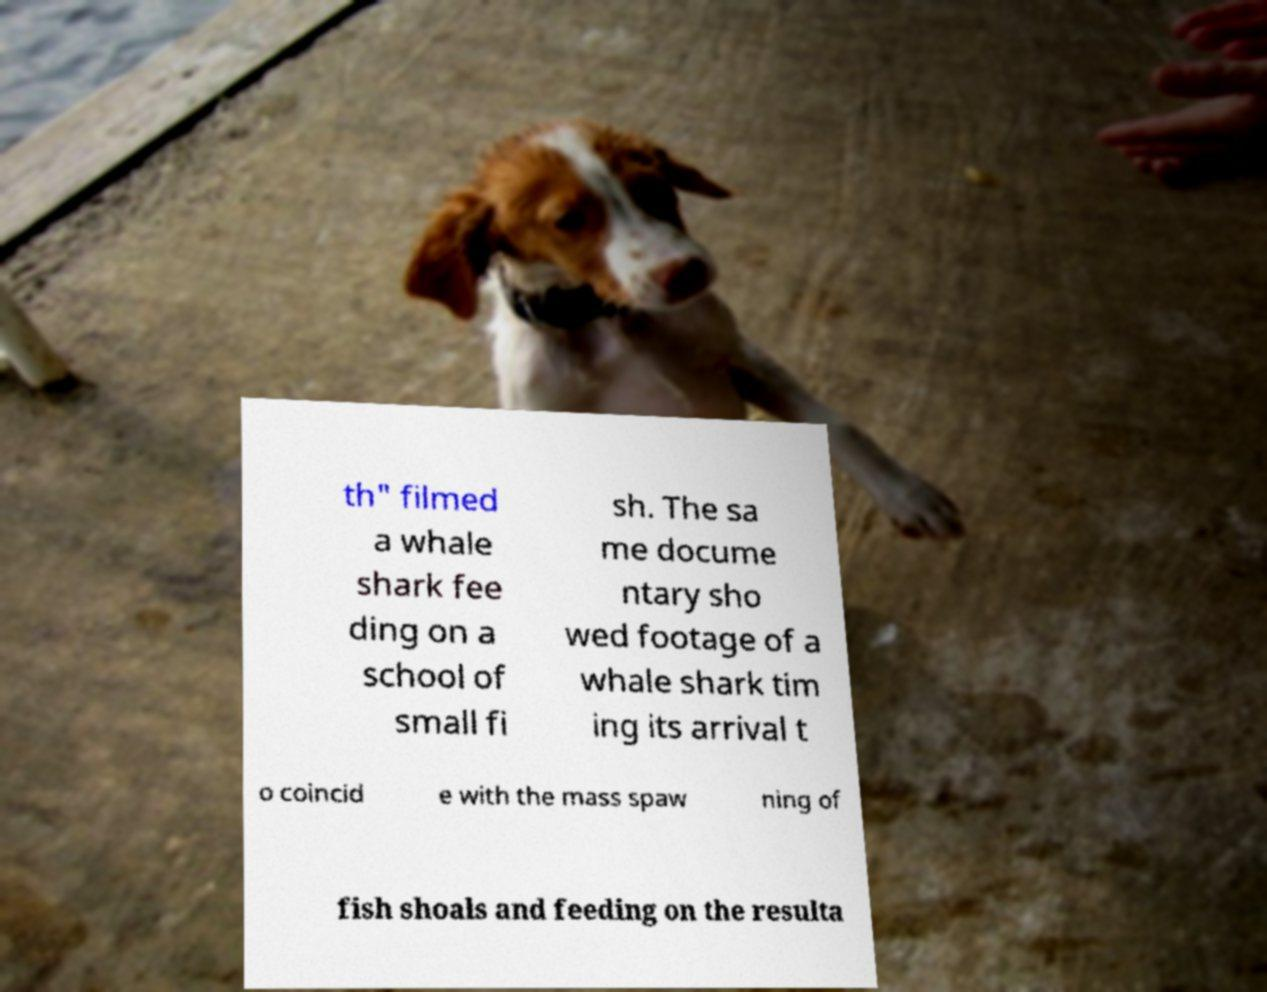Please identify and transcribe the text found in this image. th" filmed a whale shark fee ding on a school of small fi sh. The sa me docume ntary sho wed footage of a whale shark tim ing its arrival t o coincid e with the mass spaw ning of fish shoals and feeding on the resulta 